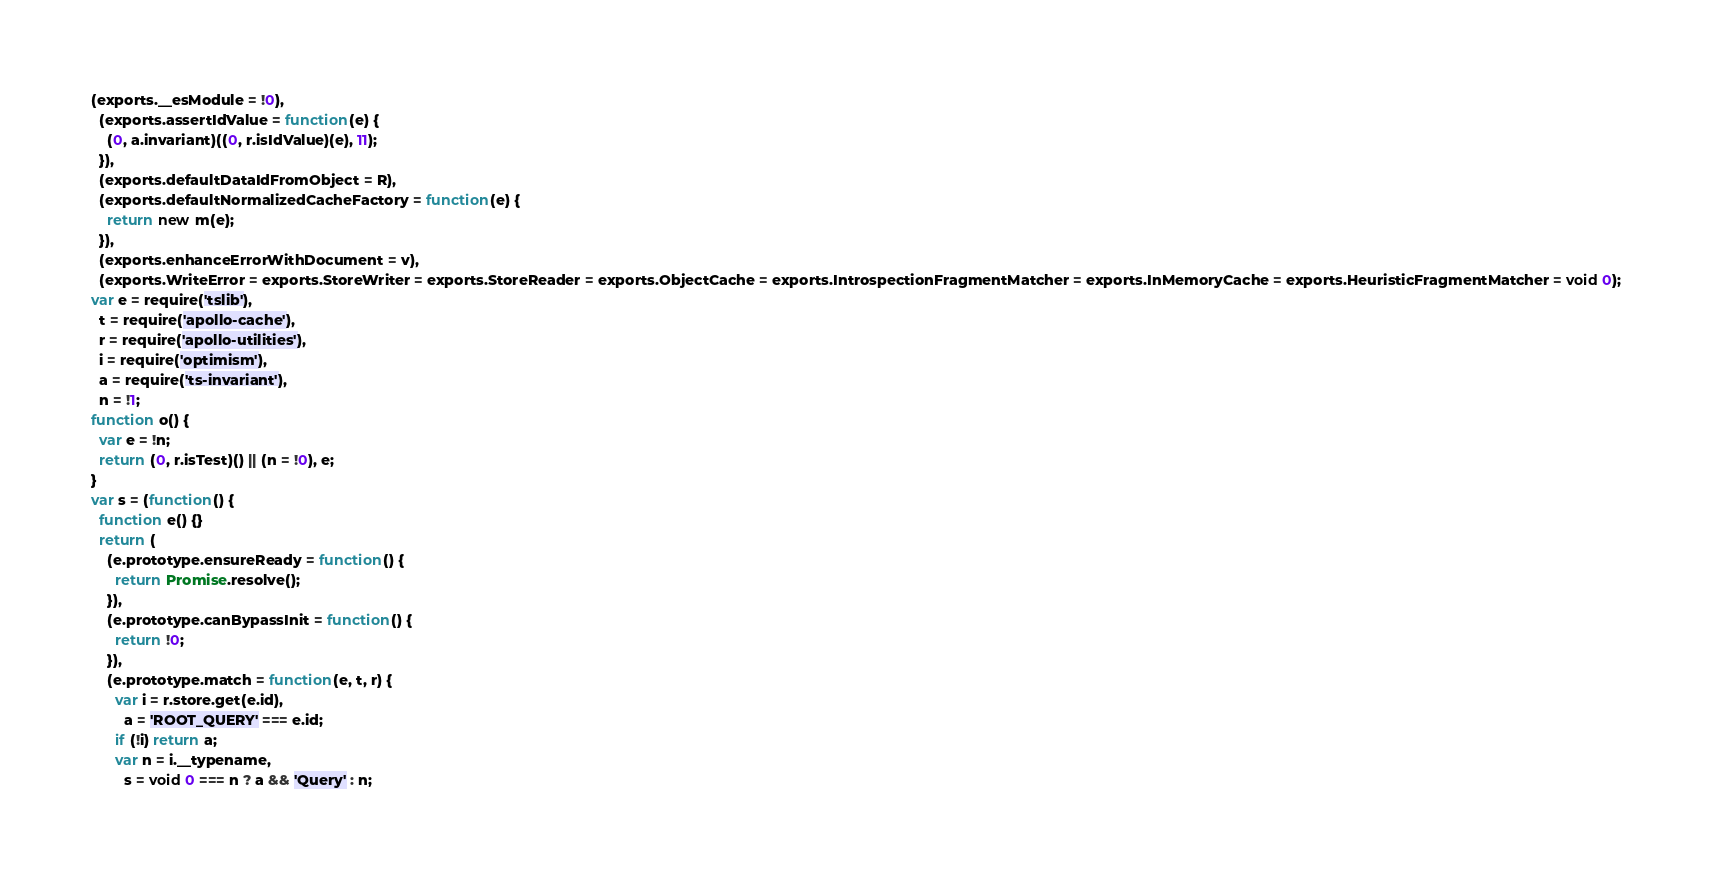<code> <loc_0><loc_0><loc_500><loc_500><_JavaScript_>(exports.__esModule = !0),
  (exports.assertIdValue = function(e) {
    (0, a.invariant)((0, r.isIdValue)(e), 11);
  }),
  (exports.defaultDataIdFromObject = R),
  (exports.defaultNormalizedCacheFactory = function(e) {
    return new m(e);
  }),
  (exports.enhanceErrorWithDocument = v),
  (exports.WriteError = exports.StoreWriter = exports.StoreReader = exports.ObjectCache = exports.IntrospectionFragmentMatcher = exports.InMemoryCache = exports.HeuristicFragmentMatcher = void 0);
var e = require('tslib'),
  t = require('apollo-cache'),
  r = require('apollo-utilities'),
  i = require('optimism'),
  a = require('ts-invariant'),
  n = !1;
function o() {
  var e = !n;
  return (0, r.isTest)() || (n = !0), e;
}
var s = (function() {
  function e() {}
  return (
    (e.prototype.ensureReady = function() {
      return Promise.resolve();
    }),
    (e.prototype.canBypassInit = function() {
      return !0;
    }),
    (e.prototype.match = function(e, t, r) {
      var i = r.store.get(e.id),
        a = 'ROOT_QUERY' === e.id;
      if (!i) return a;
      var n = i.__typename,
        s = void 0 === n ? a && 'Query' : n;</code> 